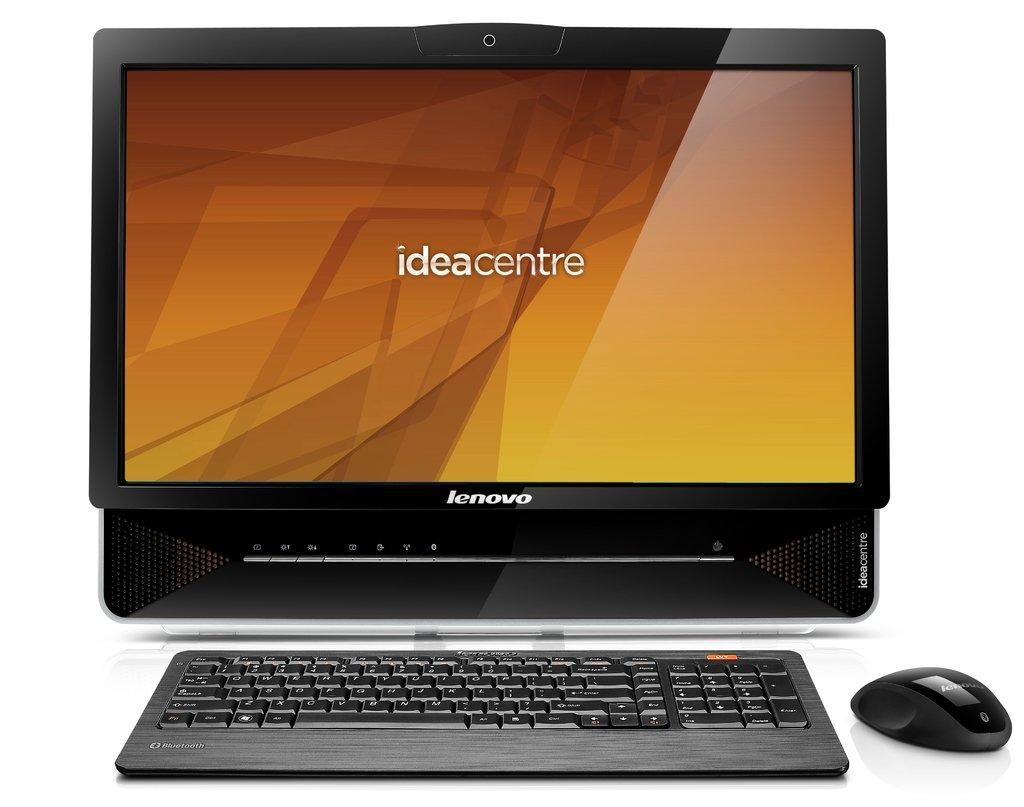<image>
Give a short and clear explanation of the subsequent image. A lenovo computer monitor has ideacentre on the screen. 